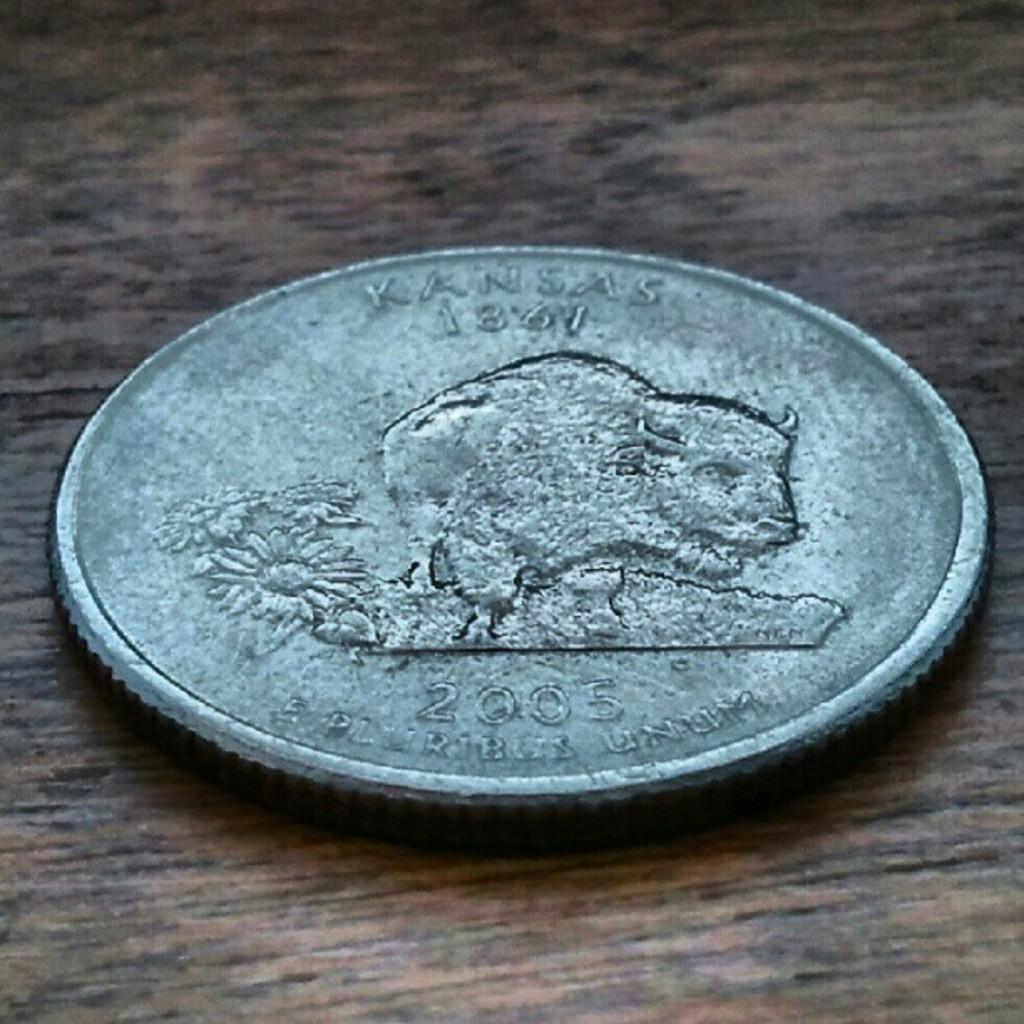Could you give a brief overview of what you see in this image? In this image we can see a coin on a wooden surface. On the coin there is something written. Also we can see an animal and flower image on the coin. 